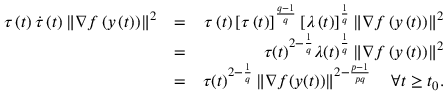Convert formula to latex. <formula><loc_0><loc_0><loc_500><loc_500>\begin{array} { r l r } { \tau \left ( t \right ) \dot { \tau } \left ( t \right ) \left \| \nabla f \left ( y \left ( t \right ) \right ) \right \| ^ { 2 } } & { = } & { \tau \left ( t \right ) \left [ \tau \left ( t \right ) \right ] ^ { \frac { q - 1 } { q } } \left [ \lambda \left ( t \right ) \right ] ^ { \frac { 1 } { q } } \left \| \nabla f \left ( y \left ( t \right ) \right ) \right \| ^ { 2 } } \\ & { = } & { \tau ( t ) ^ { 2 - \frac { 1 } { q } } \lambda ( t ) ^ { \frac { 1 } { q } } \left \| \nabla f \left ( y \left ( t \right ) \right ) \right \| ^ { 2 } } \\ & { = } & { \tau ( t ) ^ { 2 - \frac { 1 } { q } } \left \| \nabla f ( y ( t ) ) \right \| ^ { 2 - \frac { p - 1 } { p q } } \quad \forall t \geq t _ { 0 } . } \end{array}</formula> 